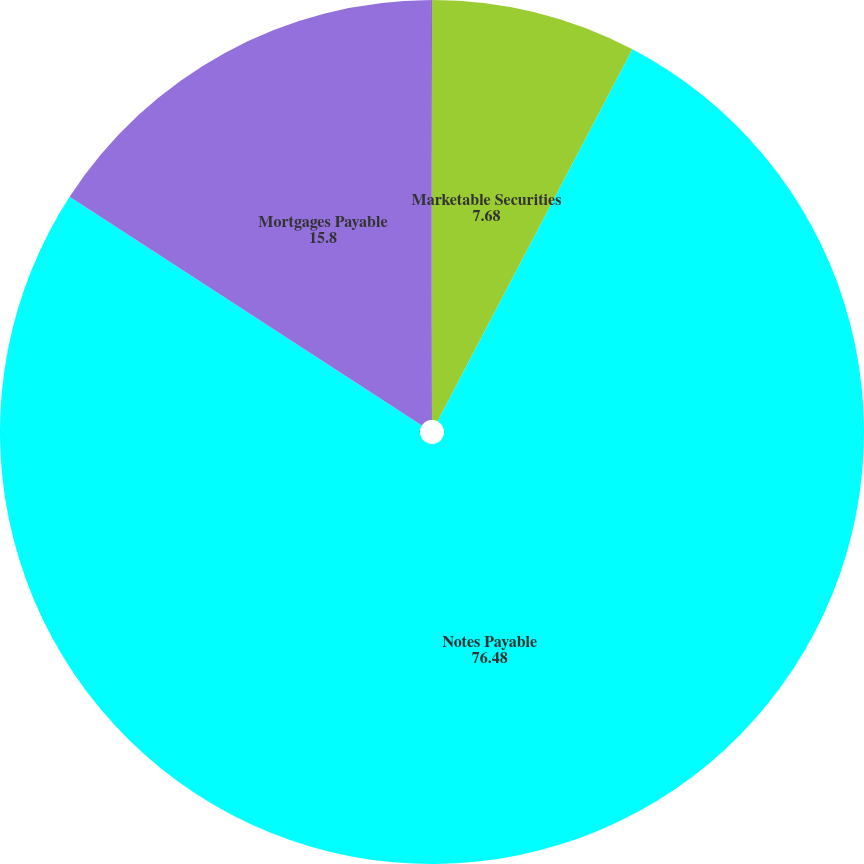Convert chart. <chart><loc_0><loc_0><loc_500><loc_500><pie_chart><fcel>Marketable Securities<fcel>Notes Payable<fcel>Mortgages Payable<fcel>Mandatorily Redeemable<nl><fcel>7.68%<fcel>76.48%<fcel>15.8%<fcel>0.04%<nl></chart> 